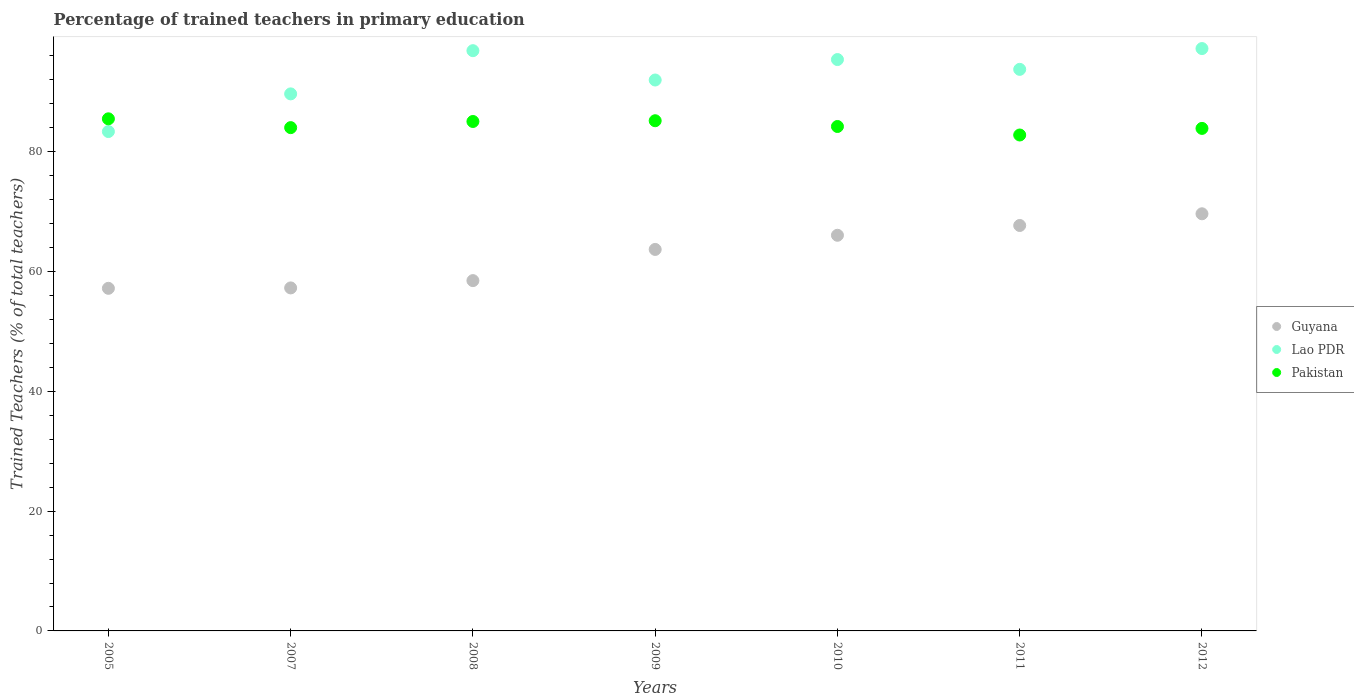How many different coloured dotlines are there?
Ensure brevity in your answer.  3. Is the number of dotlines equal to the number of legend labels?
Offer a terse response. Yes. What is the percentage of trained teachers in Guyana in 2005?
Keep it short and to the point. 57.2. Across all years, what is the maximum percentage of trained teachers in Guyana?
Keep it short and to the point. 69.65. Across all years, what is the minimum percentage of trained teachers in Pakistan?
Ensure brevity in your answer.  82.81. In which year was the percentage of trained teachers in Guyana maximum?
Your response must be concise. 2012. In which year was the percentage of trained teachers in Guyana minimum?
Give a very brief answer. 2005. What is the total percentage of trained teachers in Lao PDR in the graph?
Provide a short and direct response. 648.33. What is the difference between the percentage of trained teachers in Pakistan in 2007 and that in 2011?
Provide a succinct answer. 1.23. What is the difference between the percentage of trained teachers in Guyana in 2008 and the percentage of trained teachers in Lao PDR in 2010?
Make the answer very short. -36.91. What is the average percentage of trained teachers in Pakistan per year?
Ensure brevity in your answer.  84.39. In the year 2005, what is the difference between the percentage of trained teachers in Guyana and percentage of trained teachers in Pakistan?
Keep it short and to the point. -28.3. In how many years, is the percentage of trained teachers in Guyana greater than 40 %?
Provide a short and direct response. 7. What is the ratio of the percentage of trained teachers in Pakistan in 2005 to that in 2008?
Provide a succinct answer. 1.01. Is the percentage of trained teachers in Lao PDR in 2010 less than that in 2012?
Ensure brevity in your answer.  Yes. Is the difference between the percentage of trained teachers in Guyana in 2005 and 2008 greater than the difference between the percentage of trained teachers in Pakistan in 2005 and 2008?
Your response must be concise. No. What is the difference between the highest and the second highest percentage of trained teachers in Pakistan?
Offer a very short reply. 0.32. What is the difference between the highest and the lowest percentage of trained teachers in Pakistan?
Give a very brief answer. 2.7. Is the percentage of trained teachers in Lao PDR strictly greater than the percentage of trained teachers in Pakistan over the years?
Make the answer very short. No. How many dotlines are there?
Your response must be concise. 3. How many years are there in the graph?
Your answer should be compact. 7. Are the values on the major ticks of Y-axis written in scientific E-notation?
Provide a short and direct response. No. Does the graph contain any zero values?
Keep it short and to the point. No. How many legend labels are there?
Offer a very short reply. 3. What is the title of the graph?
Give a very brief answer. Percentage of trained teachers in primary education. What is the label or title of the X-axis?
Give a very brief answer. Years. What is the label or title of the Y-axis?
Your answer should be very brief. Trained Teachers (% of total teachers). What is the Trained Teachers (% of total teachers) in Guyana in 2005?
Provide a short and direct response. 57.2. What is the Trained Teachers (% of total teachers) in Lao PDR in 2005?
Offer a terse response. 83.38. What is the Trained Teachers (% of total teachers) in Pakistan in 2005?
Keep it short and to the point. 85.51. What is the Trained Teachers (% of total teachers) of Guyana in 2007?
Offer a very short reply. 57.27. What is the Trained Teachers (% of total teachers) of Lao PDR in 2007?
Offer a terse response. 89.67. What is the Trained Teachers (% of total teachers) of Pakistan in 2007?
Provide a short and direct response. 84.04. What is the Trained Teachers (% of total teachers) in Guyana in 2008?
Offer a very short reply. 58.49. What is the Trained Teachers (% of total teachers) in Lao PDR in 2008?
Your answer should be compact. 96.89. What is the Trained Teachers (% of total teachers) in Pakistan in 2008?
Your answer should be compact. 85.06. What is the Trained Teachers (% of total teachers) in Guyana in 2009?
Offer a very short reply. 63.7. What is the Trained Teachers (% of total teachers) in Lao PDR in 2009?
Ensure brevity in your answer.  91.99. What is the Trained Teachers (% of total teachers) of Pakistan in 2009?
Offer a terse response. 85.19. What is the Trained Teachers (% of total teachers) of Guyana in 2010?
Ensure brevity in your answer.  66.06. What is the Trained Teachers (% of total teachers) in Lao PDR in 2010?
Your answer should be very brief. 95.4. What is the Trained Teachers (% of total teachers) in Pakistan in 2010?
Give a very brief answer. 84.23. What is the Trained Teachers (% of total teachers) in Guyana in 2011?
Provide a short and direct response. 67.7. What is the Trained Teachers (% of total teachers) in Lao PDR in 2011?
Your response must be concise. 93.77. What is the Trained Teachers (% of total teachers) in Pakistan in 2011?
Keep it short and to the point. 82.81. What is the Trained Teachers (% of total teachers) of Guyana in 2012?
Offer a terse response. 69.65. What is the Trained Teachers (% of total teachers) in Lao PDR in 2012?
Keep it short and to the point. 97.24. What is the Trained Teachers (% of total teachers) in Pakistan in 2012?
Ensure brevity in your answer.  83.91. Across all years, what is the maximum Trained Teachers (% of total teachers) of Guyana?
Provide a short and direct response. 69.65. Across all years, what is the maximum Trained Teachers (% of total teachers) in Lao PDR?
Give a very brief answer. 97.24. Across all years, what is the maximum Trained Teachers (% of total teachers) of Pakistan?
Offer a terse response. 85.51. Across all years, what is the minimum Trained Teachers (% of total teachers) in Guyana?
Give a very brief answer. 57.2. Across all years, what is the minimum Trained Teachers (% of total teachers) in Lao PDR?
Your answer should be compact. 83.38. Across all years, what is the minimum Trained Teachers (% of total teachers) in Pakistan?
Offer a terse response. 82.81. What is the total Trained Teachers (% of total teachers) of Guyana in the graph?
Offer a terse response. 440.08. What is the total Trained Teachers (% of total teachers) of Lao PDR in the graph?
Give a very brief answer. 648.33. What is the total Trained Teachers (% of total teachers) of Pakistan in the graph?
Give a very brief answer. 590.73. What is the difference between the Trained Teachers (% of total teachers) of Guyana in 2005 and that in 2007?
Offer a terse response. -0.07. What is the difference between the Trained Teachers (% of total teachers) in Lao PDR in 2005 and that in 2007?
Give a very brief answer. -6.29. What is the difference between the Trained Teachers (% of total teachers) of Pakistan in 2005 and that in 2007?
Your answer should be very brief. 1.47. What is the difference between the Trained Teachers (% of total teachers) in Guyana in 2005 and that in 2008?
Your response must be concise. -1.29. What is the difference between the Trained Teachers (% of total teachers) in Lao PDR in 2005 and that in 2008?
Offer a terse response. -13.5. What is the difference between the Trained Teachers (% of total teachers) of Pakistan in 2005 and that in 2008?
Your response must be concise. 0.44. What is the difference between the Trained Teachers (% of total teachers) of Guyana in 2005 and that in 2009?
Provide a short and direct response. -6.49. What is the difference between the Trained Teachers (% of total teachers) in Lao PDR in 2005 and that in 2009?
Give a very brief answer. -8.61. What is the difference between the Trained Teachers (% of total teachers) of Pakistan in 2005 and that in 2009?
Offer a terse response. 0.32. What is the difference between the Trained Teachers (% of total teachers) of Guyana in 2005 and that in 2010?
Provide a succinct answer. -8.86. What is the difference between the Trained Teachers (% of total teachers) of Lao PDR in 2005 and that in 2010?
Offer a very short reply. -12.02. What is the difference between the Trained Teachers (% of total teachers) in Pakistan in 2005 and that in 2010?
Make the answer very short. 1.28. What is the difference between the Trained Teachers (% of total teachers) in Guyana in 2005 and that in 2011?
Give a very brief answer. -10.49. What is the difference between the Trained Teachers (% of total teachers) in Lao PDR in 2005 and that in 2011?
Your answer should be compact. -10.39. What is the difference between the Trained Teachers (% of total teachers) of Pakistan in 2005 and that in 2011?
Give a very brief answer. 2.7. What is the difference between the Trained Teachers (% of total teachers) of Guyana in 2005 and that in 2012?
Provide a short and direct response. -12.44. What is the difference between the Trained Teachers (% of total teachers) in Lao PDR in 2005 and that in 2012?
Provide a short and direct response. -13.86. What is the difference between the Trained Teachers (% of total teachers) in Pakistan in 2005 and that in 2012?
Ensure brevity in your answer.  1.6. What is the difference between the Trained Teachers (% of total teachers) of Guyana in 2007 and that in 2008?
Your answer should be very brief. -1.22. What is the difference between the Trained Teachers (% of total teachers) of Lao PDR in 2007 and that in 2008?
Give a very brief answer. -7.22. What is the difference between the Trained Teachers (% of total teachers) in Pakistan in 2007 and that in 2008?
Your answer should be very brief. -1.03. What is the difference between the Trained Teachers (% of total teachers) in Guyana in 2007 and that in 2009?
Provide a short and direct response. -6.43. What is the difference between the Trained Teachers (% of total teachers) of Lao PDR in 2007 and that in 2009?
Offer a very short reply. -2.32. What is the difference between the Trained Teachers (% of total teachers) in Pakistan in 2007 and that in 2009?
Your response must be concise. -1.15. What is the difference between the Trained Teachers (% of total teachers) in Guyana in 2007 and that in 2010?
Make the answer very short. -8.79. What is the difference between the Trained Teachers (% of total teachers) of Lao PDR in 2007 and that in 2010?
Make the answer very short. -5.73. What is the difference between the Trained Teachers (% of total teachers) of Pakistan in 2007 and that in 2010?
Offer a terse response. -0.19. What is the difference between the Trained Teachers (% of total teachers) of Guyana in 2007 and that in 2011?
Your answer should be compact. -10.42. What is the difference between the Trained Teachers (% of total teachers) of Lao PDR in 2007 and that in 2011?
Your response must be concise. -4.1. What is the difference between the Trained Teachers (% of total teachers) in Pakistan in 2007 and that in 2011?
Ensure brevity in your answer.  1.23. What is the difference between the Trained Teachers (% of total teachers) of Guyana in 2007 and that in 2012?
Make the answer very short. -12.38. What is the difference between the Trained Teachers (% of total teachers) of Lao PDR in 2007 and that in 2012?
Ensure brevity in your answer.  -7.57. What is the difference between the Trained Teachers (% of total teachers) of Pakistan in 2007 and that in 2012?
Offer a very short reply. 0.13. What is the difference between the Trained Teachers (% of total teachers) of Guyana in 2008 and that in 2009?
Offer a very short reply. -5.21. What is the difference between the Trained Teachers (% of total teachers) in Lao PDR in 2008 and that in 2009?
Keep it short and to the point. 4.9. What is the difference between the Trained Teachers (% of total teachers) in Pakistan in 2008 and that in 2009?
Offer a terse response. -0.13. What is the difference between the Trained Teachers (% of total teachers) in Guyana in 2008 and that in 2010?
Give a very brief answer. -7.57. What is the difference between the Trained Teachers (% of total teachers) of Lao PDR in 2008 and that in 2010?
Give a very brief answer. 1.48. What is the difference between the Trained Teachers (% of total teachers) of Pakistan in 2008 and that in 2010?
Make the answer very short. 0.84. What is the difference between the Trained Teachers (% of total teachers) in Guyana in 2008 and that in 2011?
Your answer should be very brief. -9.21. What is the difference between the Trained Teachers (% of total teachers) in Lao PDR in 2008 and that in 2011?
Provide a short and direct response. 3.12. What is the difference between the Trained Teachers (% of total teachers) in Pakistan in 2008 and that in 2011?
Give a very brief answer. 2.26. What is the difference between the Trained Teachers (% of total teachers) of Guyana in 2008 and that in 2012?
Provide a succinct answer. -11.16. What is the difference between the Trained Teachers (% of total teachers) of Lao PDR in 2008 and that in 2012?
Keep it short and to the point. -0.35. What is the difference between the Trained Teachers (% of total teachers) in Pakistan in 2008 and that in 2012?
Ensure brevity in your answer.  1.16. What is the difference between the Trained Teachers (% of total teachers) of Guyana in 2009 and that in 2010?
Your answer should be compact. -2.36. What is the difference between the Trained Teachers (% of total teachers) in Lao PDR in 2009 and that in 2010?
Your answer should be compact. -3.42. What is the difference between the Trained Teachers (% of total teachers) of Pakistan in 2009 and that in 2010?
Provide a succinct answer. 0.96. What is the difference between the Trained Teachers (% of total teachers) in Guyana in 2009 and that in 2011?
Make the answer very short. -4. What is the difference between the Trained Teachers (% of total teachers) in Lao PDR in 2009 and that in 2011?
Offer a very short reply. -1.78. What is the difference between the Trained Teachers (% of total teachers) in Pakistan in 2009 and that in 2011?
Ensure brevity in your answer.  2.38. What is the difference between the Trained Teachers (% of total teachers) of Guyana in 2009 and that in 2012?
Keep it short and to the point. -5.95. What is the difference between the Trained Teachers (% of total teachers) in Lao PDR in 2009 and that in 2012?
Make the answer very short. -5.25. What is the difference between the Trained Teachers (% of total teachers) of Pakistan in 2009 and that in 2012?
Make the answer very short. 1.28. What is the difference between the Trained Teachers (% of total teachers) of Guyana in 2010 and that in 2011?
Keep it short and to the point. -1.63. What is the difference between the Trained Teachers (% of total teachers) in Lao PDR in 2010 and that in 2011?
Offer a terse response. 1.64. What is the difference between the Trained Teachers (% of total teachers) of Pakistan in 2010 and that in 2011?
Ensure brevity in your answer.  1.42. What is the difference between the Trained Teachers (% of total teachers) in Guyana in 2010 and that in 2012?
Make the answer very short. -3.59. What is the difference between the Trained Teachers (% of total teachers) in Lao PDR in 2010 and that in 2012?
Your response must be concise. -1.83. What is the difference between the Trained Teachers (% of total teachers) of Pakistan in 2010 and that in 2012?
Provide a short and direct response. 0.32. What is the difference between the Trained Teachers (% of total teachers) in Guyana in 2011 and that in 2012?
Ensure brevity in your answer.  -1.95. What is the difference between the Trained Teachers (% of total teachers) in Lao PDR in 2011 and that in 2012?
Offer a very short reply. -3.47. What is the difference between the Trained Teachers (% of total teachers) of Pakistan in 2011 and that in 2012?
Provide a succinct answer. -1.1. What is the difference between the Trained Teachers (% of total teachers) of Guyana in 2005 and the Trained Teachers (% of total teachers) of Lao PDR in 2007?
Offer a very short reply. -32.47. What is the difference between the Trained Teachers (% of total teachers) of Guyana in 2005 and the Trained Teachers (% of total teachers) of Pakistan in 2007?
Offer a terse response. -26.83. What is the difference between the Trained Teachers (% of total teachers) in Lao PDR in 2005 and the Trained Teachers (% of total teachers) in Pakistan in 2007?
Your answer should be compact. -0.66. What is the difference between the Trained Teachers (% of total teachers) of Guyana in 2005 and the Trained Teachers (% of total teachers) of Lao PDR in 2008?
Give a very brief answer. -39.68. What is the difference between the Trained Teachers (% of total teachers) of Guyana in 2005 and the Trained Teachers (% of total teachers) of Pakistan in 2008?
Make the answer very short. -27.86. What is the difference between the Trained Teachers (% of total teachers) of Lao PDR in 2005 and the Trained Teachers (% of total teachers) of Pakistan in 2008?
Keep it short and to the point. -1.68. What is the difference between the Trained Teachers (% of total teachers) of Guyana in 2005 and the Trained Teachers (% of total teachers) of Lao PDR in 2009?
Provide a short and direct response. -34.78. What is the difference between the Trained Teachers (% of total teachers) in Guyana in 2005 and the Trained Teachers (% of total teachers) in Pakistan in 2009?
Ensure brevity in your answer.  -27.98. What is the difference between the Trained Teachers (% of total teachers) of Lao PDR in 2005 and the Trained Teachers (% of total teachers) of Pakistan in 2009?
Keep it short and to the point. -1.81. What is the difference between the Trained Teachers (% of total teachers) in Guyana in 2005 and the Trained Teachers (% of total teachers) in Lao PDR in 2010?
Ensure brevity in your answer.  -38.2. What is the difference between the Trained Teachers (% of total teachers) in Guyana in 2005 and the Trained Teachers (% of total teachers) in Pakistan in 2010?
Your answer should be very brief. -27.02. What is the difference between the Trained Teachers (% of total teachers) of Lao PDR in 2005 and the Trained Teachers (% of total teachers) of Pakistan in 2010?
Your response must be concise. -0.85. What is the difference between the Trained Teachers (% of total teachers) of Guyana in 2005 and the Trained Teachers (% of total teachers) of Lao PDR in 2011?
Offer a terse response. -36.56. What is the difference between the Trained Teachers (% of total teachers) of Guyana in 2005 and the Trained Teachers (% of total teachers) of Pakistan in 2011?
Your answer should be very brief. -25.6. What is the difference between the Trained Teachers (% of total teachers) of Lao PDR in 2005 and the Trained Teachers (% of total teachers) of Pakistan in 2011?
Give a very brief answer. 0.58. What is the difference between the Trained Teachers (% of total teachers) in Guyana in 2005 and the Trained Teachers (% of total teachers) in Lao PDR in 2012?
Provide a succinct answer. -40.03. What is the difference between the Trained Teachers (% of total teachers) in Guyana in 2005 and the Trained Teachers (% of total teachers) in Pakistan in 2012?
Your answer should be very brief. -26.7. What is the difference between the Trained Teachers (% of total teachers) of Lao PDR in 2005 and the Trained Teachers (% of total teachers) of Pakistan in 2012?
Ensure brevity in your answer.  -0.53. What is the difference between the Trained Teachers (% of total teachers) of Guyana in 2007 and the Trained Teachers (% of total teachers) of Lao PDR in 2008?
Your response must be concise. -39.61. What is the difference between the Trained Teachers (% of total teachers) of Guyana in 2007 and the Trained Teachers (% of total teachers) of Pakistan in 2008?
Offer a terse response. -27.79. What is the difference between the Trained Teachers (% of total teachers) of Lao PDR in 2007 and the Trained Teachers (% of total teachers) of Pakistan in 2008?
Keep it short and to the point. 4.61. What is the difference between the Trained Teachers (% of total teachers) of Guyana in 2007 and the Trained Teachers (% of total teachers) of Lao PDR in 2009?
Offer a terse response. -34.71. What is the difference between the Trained Teachers (% of total teachers) in Guyana in 2007 and the Trained Teachers (% of total teachers) in Pakistan in 2009?
Your response must be concise. -27.91. What is the difference between the Trained Teachers (% of total teachers) of Lao PDR in 2007 and the Trained Teachers (% of total teachers) of Pakistan in 2009?
Your response must be concise. 4.48. What is the difference between the Trained Teachers (% of total teachers) of Guyana in 2007 and the Trained Teachers (% of total teachers) of Lao PDR in 2010?
Provide a succinct answer. -38.13. What is the difference between the Trained Teachers (% of total teachers) in Guyana in 2007 and the Trained Teachers (% of total teachers) in Pakistan in 2010?
Your response must be concise. -26.95. What is the difference between the Trained Teachers (% of total teachers) in Lao PDR in 2007 and the Trained Teachers (% of total teachers) in Pakistan in 2010?
Provide a succinct answer. 5.44. What is the difference between the Trained Teachers (% of total teachers) in Guyana in 2007 and the Trained Teachers (% of total teachers) in Lao PDR in 2011?
Offer a terse response. -36.49. What is the difference between the Trained Teachers (% of total teachers) in Guyana in 2007 and the Trained Teachers (% of total teachers) in Pakistan in 2011?
Provide a succinct answer. -25.53. What is the difference between the Trained Teachers (% of total teachers) of Lao PDR in 2007 and the Trained Teachers (% of total teachers) of Pakistan in 2011?
Make the answer very short. 6.87. What is the difference between the Trained Teachers (% of total teachers) of Guyana in 2007 and the Trained Teachers (% of total teachers) of Lao PDR in 2012?
Your response must be concise. -39.97. What is the difference between the Trained Teachers (% of total teachers) of Guyana in 2007 and the Trained Teachers (% of total teachers) of Pakistan in 2012?
Offer a very short reply. -26.63. What is the difference between the Trained Teachers (% of total teachers) of Lao PDR in 2007 and the Trained Teachers (% of total teachers) of Pakistan in 2012?
Ensure brevity in your answer.  5.76. What is the difference between the Trained Teachers (% of total teachers) of Guyana in 2008 and the Trained Teachers (% of total teachers) of Lao PDR in 2009?
Offer a very short reply. -33.5. What is the difference between the Trained Teachers (% of total teachers) of Guyana in 2008 and the Trained Teachers (% of total teachers) of Pakistan in 2009?
Your answer should be compact. -26.7. What is the difference between the Trained Teachers (% of total teachers) of Lao PDR in 2008 and the Trained Teachers (% of total teachers) of Pakistan in 2009?
Your answer should be very brief. 11.7. What is the difference between the Trained Teachers (% of total teachers) of Guyana in 2008 and the Trained Teachers (% of total teachers) of Lao PDR in 2010?
Keep it short and to the point. -36.91. What is the difference between the Trained Teachers (% of total teachers) in Guyana in 2008 and the Trained Teachers (% of total teachers) in Pakistan in 2010?
Your answer should be very brief. -25.73. What is the difference between the Trained Teachers (% of total teachers) in Lao PDR in 2008 and the Trained Teachers (% of total teachers) in Pakistan in 2010?
Provide a short and direct response. 12.66. What is the difference between the Trained Teachers (% of total teachers) in Guyana in 2008 and the Trained Teachers (% of total teachers) in Lao PDR in 2011?
Give a very brief answer. -35.27. What is the difference between the Trained Teachers (% of total teachers) of Guyana in 2008 and the Trained Teachers (% of total teachers) of Pakistan in 2011?
Offer a very short reply. -24.31. What is the difference between the Trained Teachers (% of total teachers) in Lao PDR in 2008 and the Trained Teachers (% of total teachers) in Pakistan in 2011?
Offer a very short reply. 14.08. What is the difference between the Trained Teachers (% of total teachers) in Guyana in 2008 and the Trained Teachers (% of total teachers) in Lao PDR in 2012?
Offer a very short reply. -38.75. What is the difference between the Trained Teachers (% of total teachers) in Guyana in 2008 and the Trained Teachers (% of total teachers) in Pakistan in 2012?
Provide a short and direct response. -25.42. What is the difference between the Trained Teachers (% of total teachers) of Lao PDR in 2008 and the Trained Teachers (% of total teachers) of Pakistan in 2012?
Provide a succinct answer. 12.98. What is the difference between the Trained Teachers (% of total teachers) in Guyana in 2009 and the Trained Teachers (% of total teachers) in Lao PDR in 2010?
Your answer should be very brief. -31.7. What is the difference between the Trained Teachers (% of total teachers) in Guyana in 2009 and the Trained Teachers (% of total teachers) in Pakistan in 2010?
Offer a terse response. -20.53. What is the difference between the Trained Teachers (% of total teachers) in Lao PDR in 2009 and the Trained Teachers (% of total teachers) in Pakistan in 2010?
Your answer should be very brief. 7.76. What is the difference between the Trained Teachers (% of total teachers) in Guyana in 2009 and the Trained Teachers (% of total teachers) in Lao PDR in 2011?
Your answer should be very brief. -30.07. What is the difference between the Trained Teachers (% of total teachers) in Guyana in 2009 and the Trained Teachers (% of total teachers) in Pakistan in 2011?
Ensure brevity in your answer.  -19.11. What is the difference between the Trained Teachers (% of total teachers) in Lao PDR in 2009 and the Trained Teachers (% of total teachers) in Pakistan in 2011?
Your answer should be very brief. 9.18. What is the difference between the Trained Teachers (% of total teachers) in Guyana in 2009 and the Trained Teachers (% of total teachers) in Lao PDR in 2012?
Provide a short and direct response. -33.54. What is the difference between the Trained Teachers (% of total teachers) of Guyana in 2009 and the Trained Teachers (% of total teachers) of Pakistan in 2012?
Give a very brief answer. -20.21. What is the difference between the Trained Teachers (% of total teachers) of Lao PDR in 2009 and the Trained Teachers (% of total teachers) of Pakistan in 2012?
Give a very brief answer. 8.08. What is the difference between the Trained Teachers (% of total teachers) in Guyana in 2010 and the Trained Teachers (% of total teachers) in Lao PDR in 2011?
Your answer should be very brief. -27.7. What is the difference between the Trained Teachers (% of total teachers) of Guyana in 2010 and the Trained Teachers (% of total teachers) of Pakistan in 2011?
Keep it short and to the point. -16.74. What is the difference between the Trained Teachers (% of total teachers) of Lao PDR in 2010 and the Trained Teachers (% of total teachers) of Pakistan in 2011?
Offer a very short reply. 12.6. What is the difference between the Trained Teachers (% of total teachers) in Guyana in 2010 and the Trained Teachers (% of total teachers) in Lao PDR in 2012?
Give a very brief answer. -31.18. What is the difference between the Trained Teachers (% of total teachers) of Guyana in 2010 and the Trained Teachers (% of total teachers) of Pakistan in 2012?
Offer a very short reply. -17.84. What is the difference between the Trained Teachers (% of total teachers) of Lao PDR in 2010 and the Trained Teachers (% of total teachers) of Pakistan in 2012?
Offer a terse response. 11.5. What is the difference between the Trained Teachers (% of total teachers) in Guyana in 2011 and the Trained Teachers (% of total teachers) in Lao PDR in 2012?
Provide a short and direct response. -29.54. What is the difference between the Trained Teachers (% of total teachers) of Guyana in 2011 and the Trained Teachers (% of total teachers) of Pakistan in 2012?
Offer a very short reply. -16.21. What is the difference between the Trained Teachers (% of total teachers) of Lao PDR in 2011 and the Trained Teachers (% of total teachers) of Pakistan in 2012?
Your response must be concise. 9.86. What is the average Trained Teachers (% of total teachers) in Guyana per year?
Offer a terse response. 62.87. What is the average Trained Teachers (% of total teachers) in Lao PDR per year?
Provide a succinct answer. 92.62. What is the average Trained Teachers (% of total teachers) in Pakistan per year?
Keep it short and to the point. 84.39. In the year 2005, what is the difference between the Trained Teachers (% of total teachers) of Guyana and Trained Teachers (% of total teachers) of Lao PDR?
Your response must be concise. -26.18. In the year 2005, what is the difference between the Trained Teachers (% of total teachers) of Guyana and Trained Teachers (% of total teachers) of Pakistan?
Ensure brevity in your answer.  -28.3. In the year 2005, what is the difference between the Trained Teachers (% of total teachers) of Lao PDR and Trained Teachers (% of total teachers) of Pakistan?
Offer a terse response. -2.13. In the year 2007, what is the difference between the Trained Teachers (% of total teachers) of Guyana and Trained Teachers (% of total teachers) of Lao PDR?
Provide a short and direct response. -32.4. In the year 2007, what is the difference between the Trained Teachers (% of total teachers) of Guyana and Trained Teachers (% of total teachers) of Pakistan?
Give a very brief answer. -26.76. In the year 2007, what is the difference between the Trained Teachers (% of total teachers) of Lao PDR and Trained Teachers (% of total teachers) of Pakistan?
Keep it short and to the point. 5.63. In the year 2008, what is the difference between the Trained Teachers (% of total teachers) in Guyana and Trained Teachers (% of total teachers) in Lao PDR?
Ensure brevity in your answer.  -38.39. In the year 2008, what is the difference between the Trained Teachers (% of total teachers) in Guyana and Trained Teachers (% of total teachers) in Pakistan?
Provide a succinct answer. -26.57. In the year 2008, what is the difference between the Trained Teachers (% of total teachers) in Lao PDR and Trained Teachers (% of total teachers) in Pakistan?
Give a very brief answer. 11.82. In the year 2009, what is the difference between the Trained Teachers (% of total teachers) in Guyana and Trained Teachers (% of total teachers) in Lao PDR?
Your answer should be compact. -28.29. In the year 2009, what is the difference between the Trained Teachers (% of total teachers) in Guyana and Trained Teachers (% of total teachers) in Pakistan?
Your response must be concise. -21.49. In the year 2009, what is the difference between the Trained Teachers (% of total teachers) of Lao PDR and Trained Teachers (% of total teachers) of Pakistan?
Make the answer very short. 6.8. In the year 2010, what is the difference between the Trained Teachers (% of total teachers) in Guyana and Trained Teachers (% of total teachers) in Lao PDR?
Provide a succinct answer. -29.34. In the year 2010, what is the difference between the Trained Teachers (% of total teachers) of Guyana and Trained Teachers (% of total teachers) of Pakistan?
Offer a terse response. -18.16. In the year 2010, what is the difference between the Trained Teachers (% of total teachers) of Lao PDR and Trained Teachers (% of total teachers) of Pakistan?
Provide a succinct answer. 11.18. In the year 2011, what is the difference between the Trained Teachers (% of total teachers) of Guyana and Trained Teachers (% of total teachers) of Lao PDR?
Offer a very short reply. -26.07. In the year 2011, what is the difference between the Trained Teachers (% of total teachers) of Guyana and Trained Teachers (% of total teachers) of Pakistan?
Give a very brief answer. -15.11. In the year 2011, what is the difference between the Trained Teachers (% of total teachers) of Lao PDR and Trained Teachers (% of total teachers) of Pakistan?
Your response must be concise. 10.96. In the year 2012, what is the difference between the Trained Teachers (% of total teachers) in Guyana and Trained Teachers (% of total teachers) in Lao PDR?
Provide a short and direct response. -27.59. In the year 2012, what is the difference between the Trained Teachers (% of total teachers) of Guyana and Trained Teachers (% of total teachers) of Pakistan?
Ensure brevity in your answer.  -14.26. In the year 2012, what is the difference between the Trained Teachers (% of total teachers) in Lao PDR and Trained Teachers (% of total teachers) in Pakistan?
Provide a succinct answer. 13.33. What is the ratio of the Trained Teachers (% of total teachers) of Lao PDR in 2005 to that in 2007?
Provide a succinct answer. 0.93. What is the ratio of the Trained Teachers (% of total teachers) of Pakistan in 2005 to that in 2007?
Your answer should be compact. 1.02. What is the ratio of the Trained Teachers (% of total teachers) of Guyana in 2005 to that in 2008?
Give a very brief answer. 0.98. What is the ratio of the Trained Teachers (% of total teachers) in Lao PDR in 2005 to that in 2008?
Your answer should be compact. 0.86. What is the ratio of the Trained Teachers (% of total teachers) in Guyana in 2005 to that in 2009?
Your response must be concise. 0.9. What is the ratio of the Trained Teachers (% of total teachers) of Lao PDR in 2005 to that in 2009?
Keep it short and to the point. 0.91. What is the ratio of the Trained Teachers (% of total teachers) of Guyana in 2005 to that in 2010?
Your answer should be compact. 0.87. What is the ratio of the Trained Teachers (% of total teachers) in Lao PDR in 2005 to that in 2010?
Provide a succinct answer. 0.87. What is the ratio of the Trained Teachers (% of total teachers) in Pakistan in 2005 to that in 2010?
Offer a terse response. 1.02. What is the ratio of the Trained Teachers (% of total teachers) of Guyana in 2005 to that in 2011?
Provide a succinct answer. 0.84. What is the ratio of the Trained Teachers (% of total teachers) in Lao PDR in 2005 to that in 2011?
Your response must be concise. 0.89. What is the ratio of the Trained Teachers (% of total teachers) in Pakistan in 2005 to that in 2011?
Offer a very short reply. 1.03. What is the ratio of the Trained Teachers (% of total teachers) in Guyana in 2005 to that in 2012?
Ensure brevity in your answer.  0.82. What is the ratio of the Trained Teachers (% of total teachers) of Lao PDR in 2005 to that in 2012?
Provide a short and direct response. 0.86. What is the ratio of the Trained Teachers (% of total teachers) of Pakistan in 2005 to that in 2012?
Your response must be concise. 1.02. What is the ratio of the Trained Teachers (% of total teachers) in Guyana in 2007 to that in 2008?
Offer a terse response. 0.98. What is the ratio of the Trained Teachers (% of total teachers) of Lao PDR in 2007 to that in 2008?
Offer a terse response. 0.93. What is the ratio of the Trained Teachers (% of total teachers) of Pakistan in 2007 to that in 2008?
Give a very brief answer. 0.99. What is the ratio of the Trained Teachers (% of total teachers) of Guyana in 2007 to that in 2009?
Your response must be concise. 0.9. What is the ratio of the Trained Teachers (% of total teachers) of Lao PDR in 2007 to that in 2009?
Offer a very short reply. 0.97. What is the ratio of the Trained Teachers (% of total teachers) of Pakistan in 2007 to that in 2009?
Make the answer very short. 0.99. What is the ratio of the Trained Teachers (% of total teachers) in Guyana in 2007 to that in 2010?
Keep it short and to the point. 0.87. What is the ratio of the Trained Teachers (% of total teachers) of Lao PDR in 2007 to that in 2010?
Offer a very short reply. 0.94. What is the ratio of the Trained Teachers (% of total teachers) in Pakistan in 2007 to that in 2010?
Keep it short and to the point. 1. What is the ratio of the Trained Teachers (% of total teachers) of Guyana in 2007 to that in 2011?
Make the answer very short. 0.85. What is the ratio of the Trained Teachers (% of total teachers) of Lao PDR in 2007 to that in 2011?
Provide a short and direct response. 0.96. What is the ratio of the Trained Teachers (% of total teachers) in Pakistan in 2007 to that in 2011?
Keep it short and to the point. 1.01. What is the ratio of the Trained Teachers (% of total teachers) of Guyana in 2007 to that in 2012?
Keep it short and to the point. 0.82. What is the ratio of the Trained Teachers (% of total teachers) in Lao PDR in 2007 to that in 2012?
Provide a succinct answer. 0.92. What is the ratio of the Trained Teachers (% of total teachers) of Guyana in 2008 to that in 2009?
Offer a terse response. 0.92. What is the ratio of the Trained Teachers (% of total teachers) in Lao PDR in 2008 to that in 2009?
Keep it short and to the point. 1.05. What is the ratio of the Trained Teachers (% of total teachers) in Pakistan in 2008 to that in 2009?
Provide a short and direct response. 1. What is the ratio of the Trained Teachers (% of total teachers) of Guyana in 2008 to that in 2010?
Ensure brevity in your answer.  0.89. What is the ratio of the Trained Teachers (% of total teachers) of Lao PDR in 2008 to that in 2010?
Provide a succinct answer. 1.02. What is the ratio of the Trained Teachers (% of total teachers) in Pakistan in 2008 to that in 2010?
Your answer should be compact. 1.01. What is the ratio of the Trained Teachers (% of total teachers) in Guyana in 2008 to that in 2011?
Provide a short and direct response. 0.86. What is the ratio of the Trained Teachers (% of total teachers) of Lao PDR in 2008 to that in 2011?
Your answer should be very brief. 1.03. What is the ratio of the Trained Teachers (% of total teachers) of Pakistan in 2008 to that in 2011?
Ensure brevity in your answer.  1.03. What is the ratio of the Trained Teachers (% of total teachers) of Guyana in 2008 to that in 2012?
Offer a terse response. 0.84. What is the ratio of the Trained Teachers (% of total teachers) of Lao PDR in 2008 to that in 2012?
Make the answer very short. 1. What is the ratio of the Trained Teachers (% of total teachers) in Pakistan in 2008 to that in 2012?
Offer a terse response. 1.01. What is the ratio of the Trained Teachers (% of total teachers) in Guyana in 2009 to that in 2010?
Provide a short and direct response. 0.96. What is the ratio of the Trained Teachers (% of total teachers) in Lao PDR in 2009 to that in 2010?
Your answer should be compact. 0.96. What is the ratio of the Trained Teachers (% of total teachers) of Pakistan in 2009 to that in 2010?
Your answer should be very brief. 1.01. What is the ratio of the Trained Teachers (% of total teachers) of Guyana in 2009 to that in 2011?
Provide a succinct answer. 0.94. What is the ratio of the Trained Teachers (% of total teachers) in Lao PDR in 2009 to that in 2011?
Make the answer very short. 0.98. What is the ratio of the Trained Teachers (% of total teachers) of Pakistan in 2009 to that in 2011?
Provide a short and direct response. 1.03. What is the ratio of the Trained Teachers (% of total teachers) of Guyana in 2009 to that in 2012?
Provide a succinct answer. 0.91. What is the ratio of the Trained Teachers (% of total teachers) in Lao PDR in 2009 to that in 2012?
Make the answer very short. 0.95. What is the ratio of the Trained Teachers (% of total teachers) of Pakistan in 2009 to that in 2012?
Provide a short and direct response. 1.02. What is the ratio of the Trained Teachers (% of total teachers) of Guyana in 2010 to that in 2011?
Your response must be concise. 0.98. What is the ratio of the Trained Teachers (% of total teachers) in Lao PDR in 2010 to that in 2011?
Provide a short and direct response. 1.02. What is the ratio of the Trained Teachers (% of total teachers) in Pakistan in 2010 to that in 2011?
Make the answer very short. 1.02. What is the ratio of the Trained Teachers (% of total teachers) of Guyana in 2010 to that in 2012?
Offer a terse response. 0.95. What is the ratio of the Trained Teachers (% of total teachers) in Lao PDR in 2010 to that in 2012?
Provide a short and direct response. 0.98. What is the ratio of the Trained Teachers (% of total teachers) in Guyana in 2011 to that in 2012?
Give a very brief answer. 0.97. What is the ratio of the Trained Teachers (% of total teachers) in Lao PDR in 2011 to that in 2012?
Your response must be concise. 0.96. What is the ratio of the Trained Teachers (% of total teachers) in Pakistan in 2011 to that in 2012?
Your response must be concise. 0.99. What is the difference between the highest and the second highest Trained Teachers (% of total teachers) of Guyana?
Keep it short and to the point. 1.95. What is the difference between the highest and the second highest Trained Teachers (% of total teachers) in Lao PDR?
Keep it short and to the point. 0.35. What is the difference between the highest and the second highest Trained Teachers (% of total teachers) of Pakistan?
Give a very brief answer. 0.32. What is the difference between the highest and the lowest Trained Teachers (% of total teachers) of Guyana?
Your response must be concise. 12.44. What is the difference between the highest and the lowest Trained Teachers (% of total teachers) in Lao PDR?
Provide a short and direct response. 13.86. What is the difference between the highest and the lowest Trained Teachers (% of total teachers) in Pakistan?
Keep it short and to the point. 2.7. 